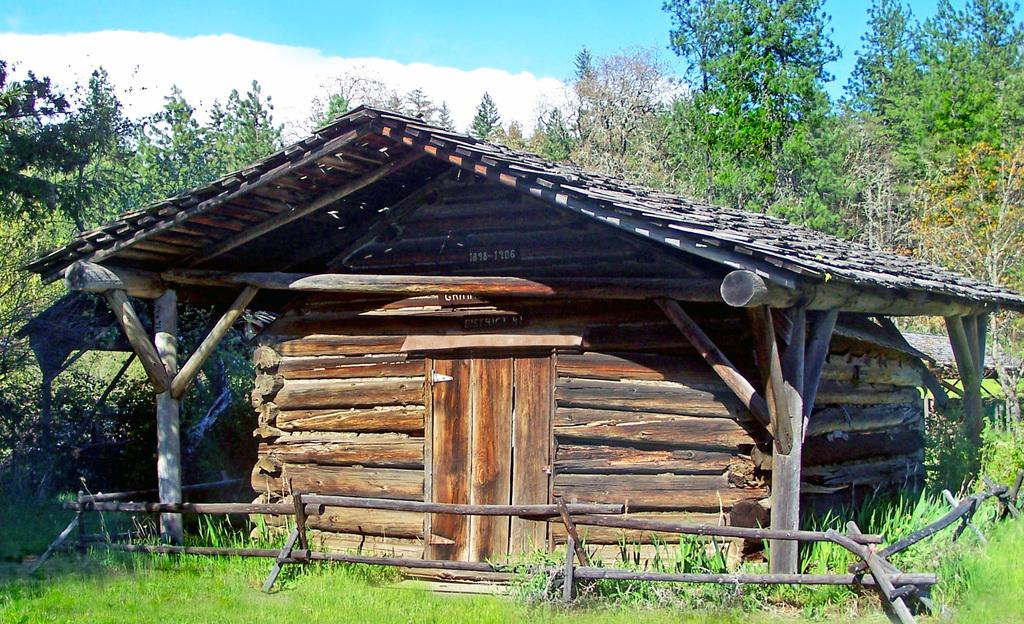What type of structure is present in the image? There is a wooden shed in the image. What type of vegetation can be seen in the image? There are trees and grass in the image. What is visible in the background of the image? The sky is visible in the image. What can be observed in the sky? There are clouds in the sky. Where is the writer sitting in the image? There is no writer present in the image. How many babies are visible in the image? There are no babies present in the image. 